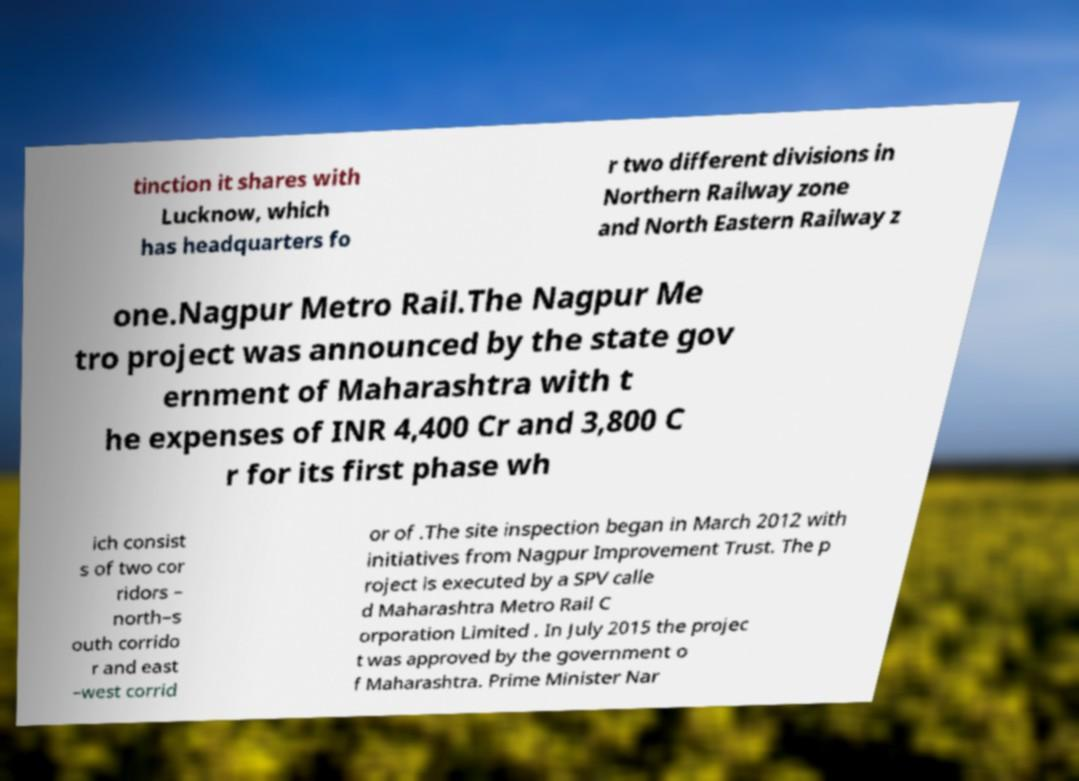What messages or text are displayed in this image? I need them in a readable, typed format. tinction it shares with Lucknow, which has headquarters fo r two different divisions in Northern Railway zone and North Eastern Railway z one.Nagpur Metro Rail.The Nagpur Me tro project was announced by the state gov ernment of Maharashtra with t he expenses of INR 4,400 Cr and 3,800 C r for its first phase wh ich consist s of two cor ridors – north–s outh corrido r and east –west corrid or of .The site inspection began in March 2012 with initiatives from Nagpur Improvement Trust. The p roject is executed by a SPV calle d Maharashtra Metro Rail C orporation Limited . In July 2015 the projec t was approved by the government o f Maharashtra. Prime Minister Nar 